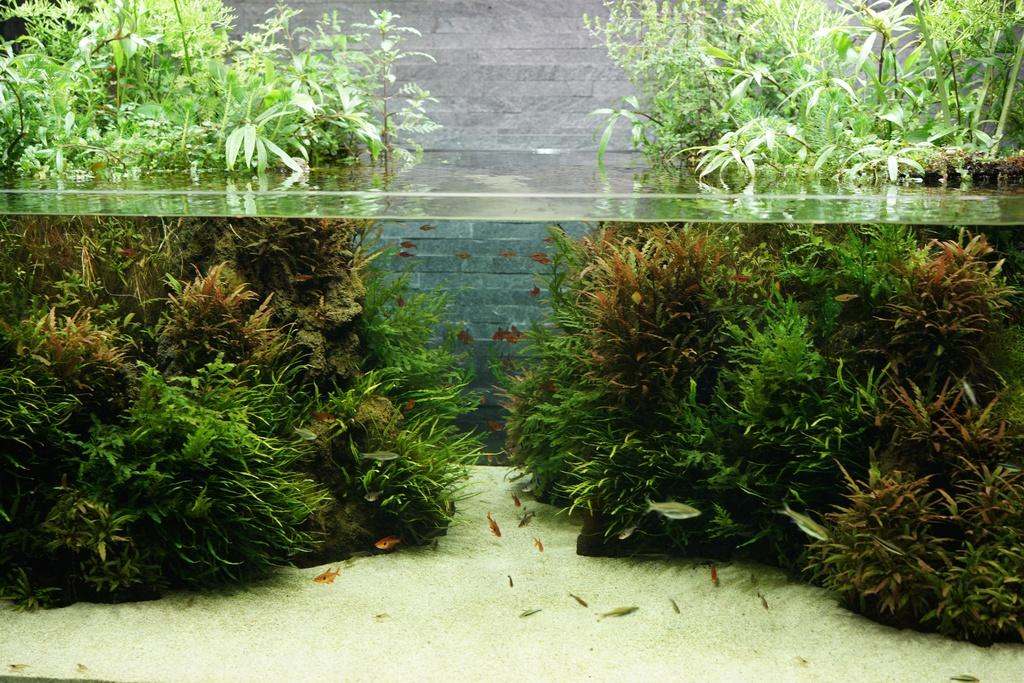What is the primary element in the image? There is water in the image. What can be found swimming in the water? There are fishes in the water. What type of vegetation is visible in the image? There are plants visible in the image. What is located behind the plants? There is a wall behind the plants. What committee is responsible for the channel in the image? There is no channel or committee mentioned in the image; it features water with fishes and plants. 